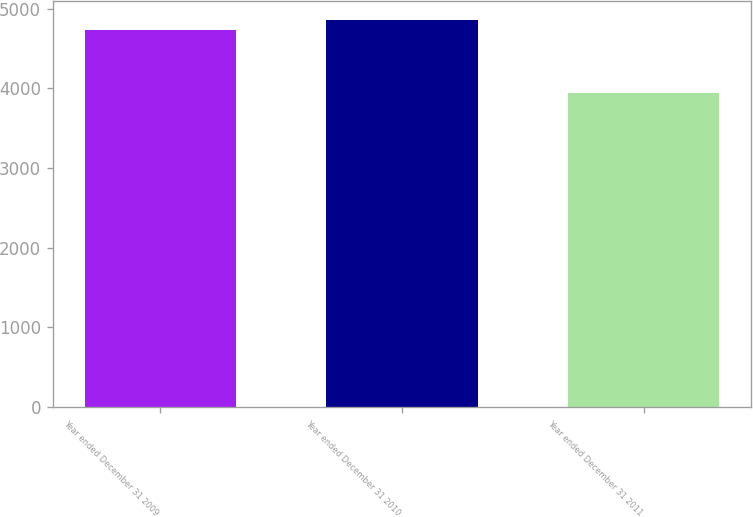Convert chart to OTSL. <chart><loc_0><loc_0><loc_500><loc_500><bar_chart><fcel>Year ended December 31 2009<fcel>Year ended December 31 2010<fcel>Year ended December 31 2011<nl><fcel>4741<fcel>4860<fcel>3939<nl></chart> 